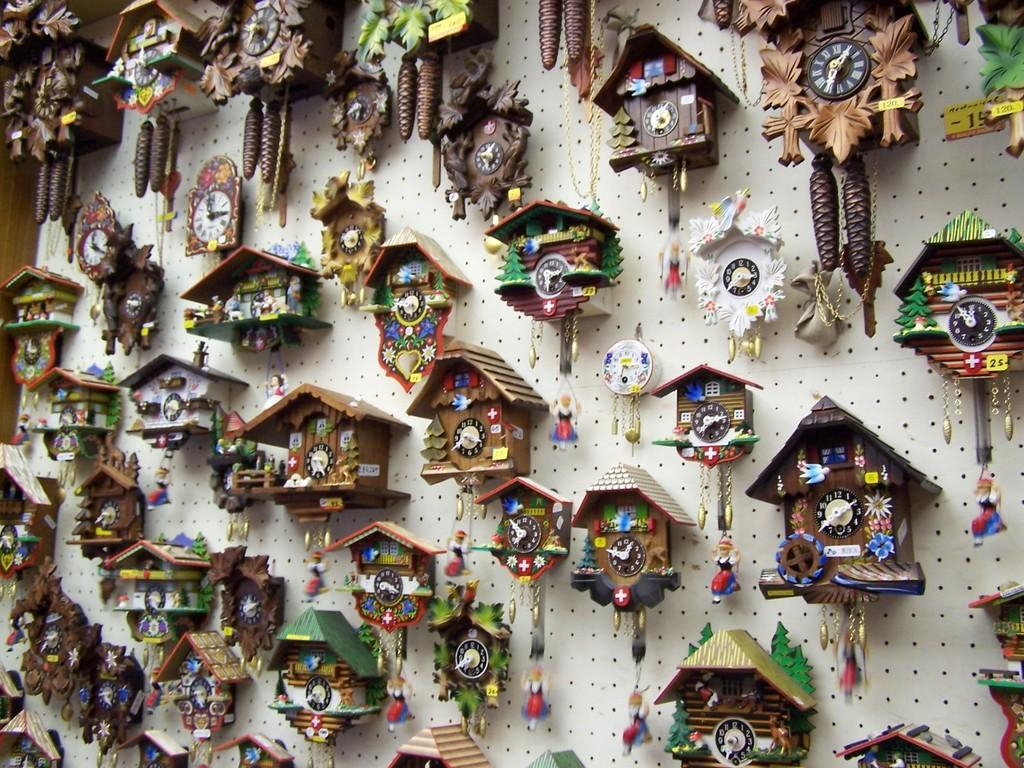What type of objects are featured in the image? There are many clocks in the image. Can you describe the specific type of clocks in the image? There are cuckoo clocks in the image. Where are the clocks located in the image? The clocks are attached to a wall. What type of quilt is draped over the cuckoo clocks in the image? There is no quilt present in the image; it only features cuckoo clocks attached to a wall. 